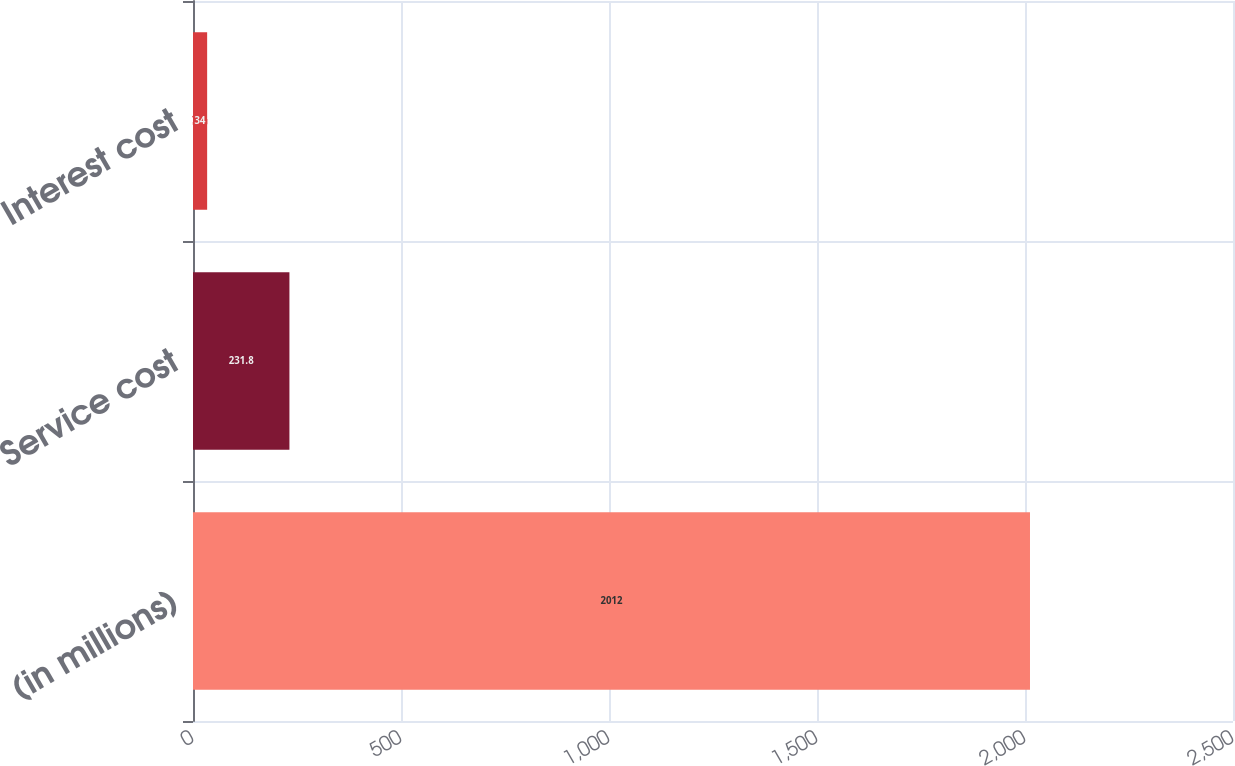Convert chart. <chart><loc_0><loc_0><loc_500><loc_500><bar_chart><fcel>(in millions)<fcel>Service cost<fcel>Interest cost<nl><fcel>2012<fcel>231.8<fcel>34<nl></chart> 